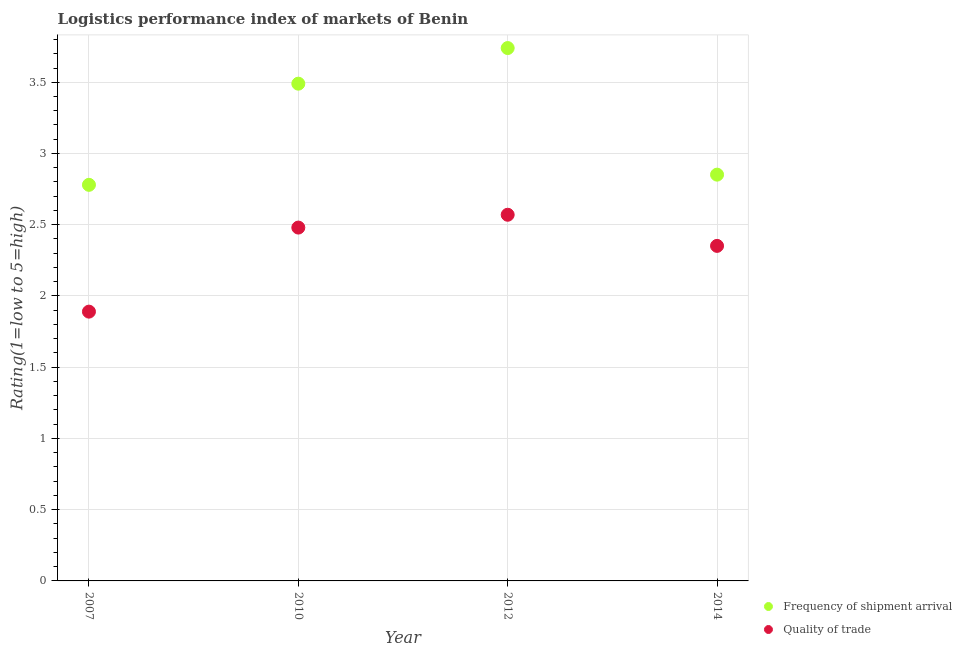How many different coloured dotlines are there?
Provide a succinct answer. 2. What is the lpi of frequency of shipment arrival in 2010?
Your response must be concise. 3.49. Across all years, what is the maximum lpi of frequency of shipment arrival?
Provide a short and direct response. 3.74. Across all years, what is the minimum lpi of frequency of shipment arrival?
Your answer should be very brief. 2.78. In which year was the lpi quality of trade maximum?
Your response must be concise. 2012. In which year was the lpi of frequency of shipment arrival minimum?
Your answer should be compact. 2007. What is the total lpi quality of trade in the graph?
Offer a very short reply. 9.29. What is the difference between the lpi of frequency of shipment arrival in 2010 and that in 2014?
Ensure brevity in your answer.  0.64. What is the difference between the lpi of frequency of shipment arrival in 2007 and the lpi quality of trade in 2010?
Give a very brief answer. 0.3. What is the average lpi quality of trade per year?
Ensure brevity in your answer.  2.32. In the year 2010, what is the difference between the lpi quality of trade and lpi of frequency of shipment arrival?
Offer a very short reply. -1.01. What is the ratio of the lpi quality of trade in 2010 to that in 2012?
Your answer should be compact. 0.96. What is the difference between the highest and the second highest lpi quality of trade?
Ensure brevity in your answer.  0.09. What is the difference between the highest and the lowest lpi quality of trade?
Your answer should be compact. 0.68. In how many years, is the lpi quality of trade greater than the average lpi quality of trade taken over all years?
Give a very brief answer. 3. Does the lpi quality of trade monotonically increase over the years?
Offer a terse response. No. How many dotlines are there?
Provide a short and direct response. 2. What is the difference between two consecutive major ticks on the Y-axis?
Your response must be concise. 0.5. Does the graph contain any zero values?
Your answer should be compact. No. How are the legend labels stacked?
Your response must be concise. Vertical. What is the title of the graph?
Your answer should be compact. Logistics performance index of markets of Benin. What is the label or title of the X-axis?
Your answer should be compact. Year. What is the label or title of the Y-axis?
Your answer should be very brief. Rating(1=low to 5=high). What is the Rating(1=low to 5=high) in Frequency of shipment arrival in 2007?
Your response must be concise. 2.78. What is the Rating(1=low to 5=high) in Quality of trade in 2007?
Your answer should be compact. 1.89. What is the Rating(1=low to 5=high) in Frequency of shipment arrival in 2010?
Ensure brevity in your answer.  3.49. What is the Rating(1=low to 5=high) of Quality of trade in 2010?
Your response must be concise. 2.48. What is the Rating(1=low to 5=high) in Frequency of shipment arrival in 2012?
Your response must be concise. 3.74. What is the Rating(1=low to 5=high) in Quality of trade in 2012?
Make the answer very short. 2.57. What is the Rating(1=low to 5=high) in Frequency of shipment arrival in 2014?
Offer a very short reply. 2.85. What is the Rating(1=low to 5=high) of Quality of trade in 2014?
Provide a succinct answer. 2.35. Across all years, what is the maximum Rating(1=low to 5=high) in Frequency of shipment arrival?
Keep it short and to the point. 3.74. Across all years, what is the maximum Rating(1=low to 5=high) in Quality of trade?
Provide a short and direct response. 2.57. Across all years, what is the minimum Rating(1=low to 5=high) of Frequency of shipment arrival?
Provide a short and direct response. 2.78. Across all years, what is the minimum Rating(1=low to 5=high) of Quality of trade?
Make the answer very short. 1.89. What is the total Rating(1=low to 5=high) in Frequency of shipment arrival in the graph?
Keep it short and to the point. 12.86. What is the total Rating(1=low to 5=high) of Quality of trade in the graph?
Provide a succinct answer. 9.29. What is the difference between the Rating(1=low to 5=high) in Frequency of shipment arrival in 2007 and that in 2010?
Keep it short and to the point. -0.71. What is the difference between the Rating(1=low to 5=high) of Quality of trade in 2007 and that in 2010?
Your answer should be very brief. -0.59. What is the difference between the Rating(1=low to 5=high) in Frequency of shipment arrival in 2007 and that in 2012?
Your response must be concise. -0.96. What is the difference between the Rating(1=low to 5=high) of Quality of trade in 2007 and that in 2012?
Provide a succinct answer. -0.68. What is the difference between the Rating(1=low to 5=high) of Frequency of shipment arrival in 2007 and that in 2014?
Offer a very short reply. -0.07. What is the difference between the Rating(1=low to 5=high) of Quality of trade in 2007 and that in 2014?
Ensure brevity in your answer.  -0.46. What is the difference between the Rating(1=low to 5=high) in Quality of trade in 2010 and that in 2012?
Make the answer very short. -0.09. What is the difference between the Rating(1=low to 5=high) of Frequency of shipment arrival in 2010 and that in 2014?
Provide a succinct answer. 0.64. What is the difference between the Rating(1=low to 5=high) in Quality of trade in 2010 and that in 2014?
Ensure brevity in your answer.  0.13. What is the difference between the Rating(1=low to 5=high) of Frequency of shipment arrival in 2012 and that in 2014?
Make the answer very short. 0.89. What is the difference between the Rating(1=low to 5=high) of Quality of trade in 2012 and that in 2014?
Your answer should be very brief. 0.22. What is the difference between the Rating(1=low to 5=high) of Frequency of shipment arrival in 2007 and the Rating(1=low to 5=high) of Quality of trade in 2010?
Offer a terse response. 0.3. What is the difference between the Rating(1=low to 5=high) of Frequency of shipment arrival in 2007 and the Rating(1=low to 5=high) of Quality of trade in 2012?
Offer a terse response. 0.21. What is the difference between the Rating(1=low to 5=high) in Frequency of shipment arrival in 2007 and the Rating(1=low to 5=high) in Quality of trade in 2014?
Make the answer very short. 0.43. What is the difference between the Rating(1=low to 5=high) of Frequency of shipment arrival in 2010 and the Rating(1=low to 5=high) of Quality of trade in 2012?
Provide a short and direct response. 0.92. What is the difference between the Rating(1=low to 5=high) of Frequency of shipment arrival in 2010 and the Rating(1=low to 5=high) of Quality of trade in 2014?
Ensure brevity in your answer.  1.14. What is the difference between the Rating(1=low to 5=high) in Frequency of shipment arrival in 2012 and the Rating(1=low to 5=high) in Quality of trade in 2014?
Your answer should be compact. 1.39. What is the average Rating(1=low to 5=high) in Frequency of shipment arrival per year?
Provide a short and direct response. 3.22. What is the average Rating(1=low to 5=high) in Quality of trade per year?
Your answer should be compact. 2.32. In the year 2007, what is the difference between the Rating(1=low to 5=high) of Frequency of shipment arrival and Rating(1=low to 5=high) of Quality of trade?
Offer a very short reply. 0.89. In the year 2012, what is the difference between the Rating(1=low to 5=high) of Frequency of shipment arrival and Rating(1=low to 5=high) of Quality of trade?
Your answer should be very brief. 1.17. What is the ratio of the Rating(1=low to 5=high) in Frequency of shipment arrival in 2007 to that in 2010?
Offer a terse response. 0.8. What is the ratio of the Rating(1=low to 5=high) in Quality of trade in 2007 to that in 2010?
Offer a very short reply. 0.76. What is the ratio of the Rating(1=low to 5=high) in Frequency of shipment arrival in 2007 to that in 2012?
Keep it short and to the point. 0.74. What is the ratio of the Rating(1=low to 5=high) in Quality of trade in 2007 to that in 2012?
Give a very brief answer. 0.74. What is the ratio of the Rating(1=low to 5=high) in Frequency of shipment arrival in 2007 to that in 2014?
Keep it short and to the point. 0.97. What is the ratio of the Rating(1=low to 5=high) of Quality of trade in 2007 to that in 2014?
Ensure brevity in your answer.  0.8. What is the ratio of the Rating(1=low to 5=high) of Frequency of shipment arrival in 2010 to that in 2012?
Your answer should be compact. 0.93. What is the ratio of the Rating(1=low to 5=high) in Quality of trade in 2010 to that in 2012?
Your answer should be very brief. 0.96. What is the ratio of the Rating(1=low to 5=high) of Frequency of shipment arrival in 2010 to that in 2014?
Ensure brevity in your answer.  1.22. What is the ratio of the Rating(1=low to 5=high) in Quality of trade in 2010 to that in 2014?
Keep it short and to the point. 1.05. What is the ratio of the Rating(1=low to 5=high) of Frequency of shipment arrival in 2012 to that in 2014?
Offer a very short reply. 1.31. What is the ratio of the Rating(1=low to 5=high) in Quality of trade in 2012 to that in 2014?
Provide a succinct answer. 1.09. What is the difference between the highest and the second highest Rating(1=low to 5=high) in Frequency of shipment arrival?
Your answer should be very brief. 0.25. What is the difference between the highest and the second highest Rating(1=low to 5=high) of Quality of trade?
Ensure brevity in your answer.  0.09. What is the difference between the highest and the lowest Rating(1=low to 5=high) of Quality of trade?
Offer a terse response. 0.68. 